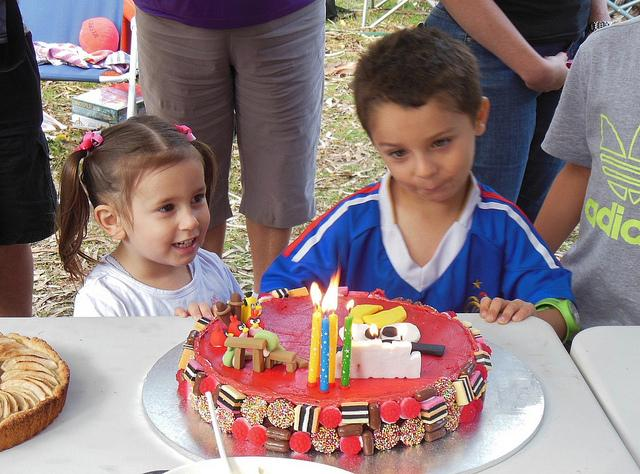When will this girl be old enough for Kindergarten?

Choices:
A) 3 years
B) 1 year
C) 2 years
D) this year 1 year 